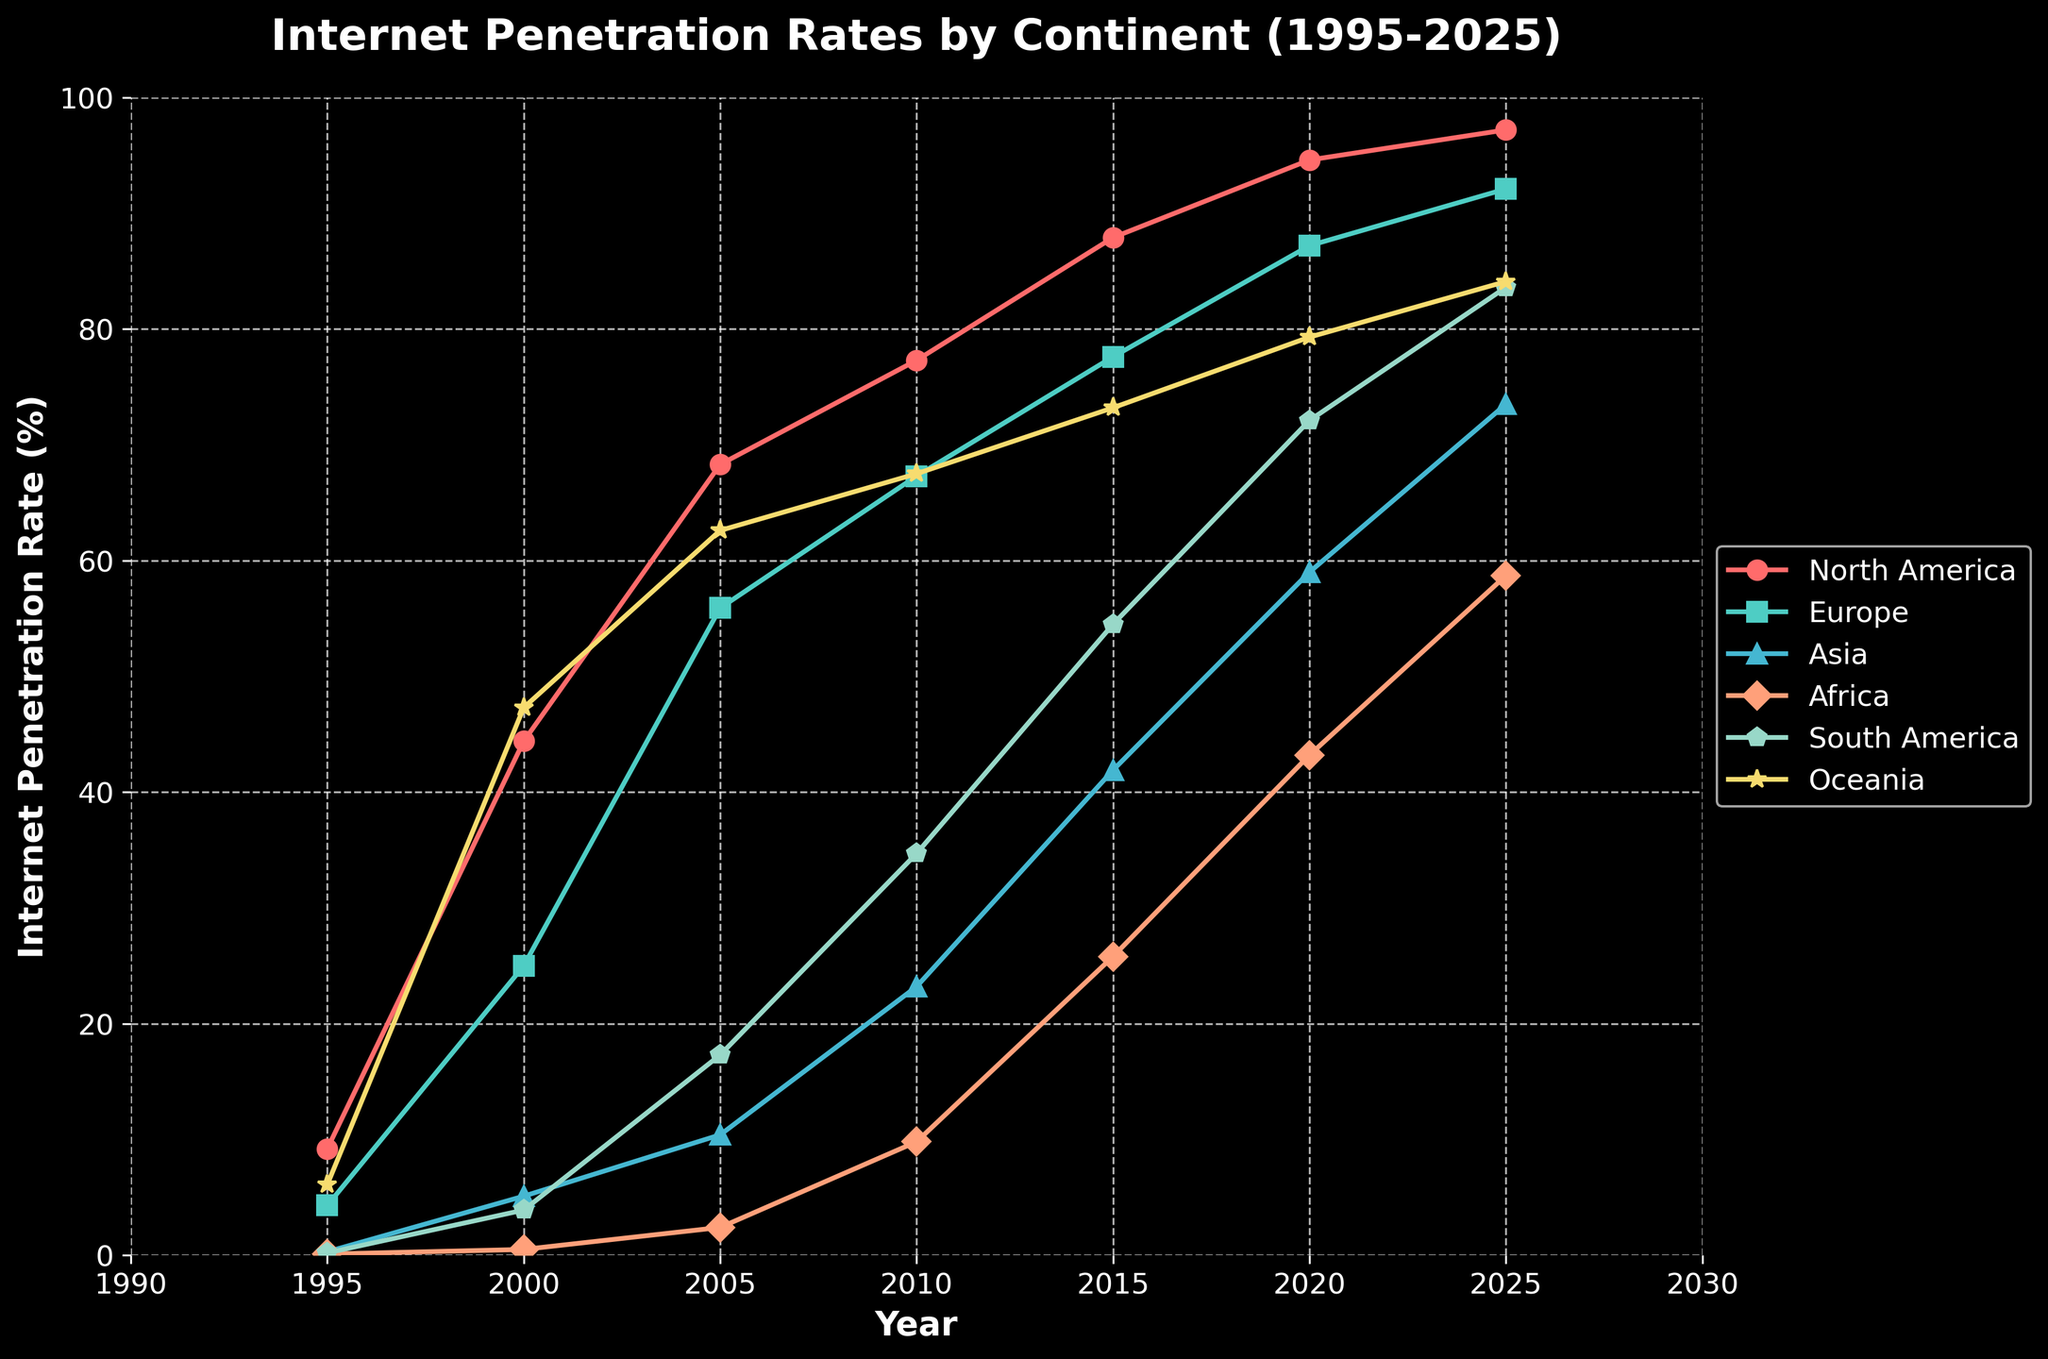What continent has the lowest internet penetration rate in 2020? According to the figure, Africa has the lowest internet penetration rate in 2020, as indicated by the value closest to the bottom of the chart for that year.
Answer: Africa Which continent showed the greatest increase in internet penetration rate from 1995 to 2025? By looking at the difference in penetration rates from 1995 to 2025 for all continents, Asia shows the greatest increase, going from 0.3% in 1995 to 73.5% in 2025, an increase of 73.2%.
Answer: Asia In 2010, which two continents had nearly identical internet penetration rates? From the figure, in 2010, North America and Oceania had nearly identical internet penetration rates, both around 67.3% and 67.5% respectively.
Answer: North America and Oceania What is the average internet penetration rate across all continents in the year 2000? Add the penetration rates for all continents in 2000 and divide by the number of continents: (44.4 + 25.0 + 5.1 + 0.5 + 3.9 + 47.3) / 6 = 126.2 / 6 = 21.03%.
Answer: 21.03% By how much did the internet penetration rate in Africa increase between 2005 and 2015? Subtract the rate in 2005 from the rate in 2015 for Africa: 25.8 - 2.4 = 23.4%.
Answer: 23.4% Which continent is represented by the line colored green and what is its internet penetration rate in 2025? By looking at the color for Oceania which is green, its penetration rate for 2025 can be identified as 84.1%.
Answer: Oceania, 84.1% Comparing 2015 to 2020, which continent had the smallest increase in internet penetration rate? Calculate the difference from 2015 to 2020 for each continent and find the smallest: (North America: 6.7%, Europe: 9.6%, Asia: 17.1%, Africa: 17.4%, South America: 17.6%, Oceania: 6.1%). Oceania has the smallest increase with 6.1%.
Answer: Oceania What is the sum of the internet penetration rates for North America and Europe in 2005? Add the rates for North America and Europe in 2005: 68.3 + 55.9 = 124.2%.
Answer: 124.2% Which continent's penetration rate is predicted to be closest to 75% in 2025? From the prediction for 2025, European and Asian rates are near 75%, but Asia's rate is closer at 73.5% compared to Europe's 92.1%.
Answer: Asia 